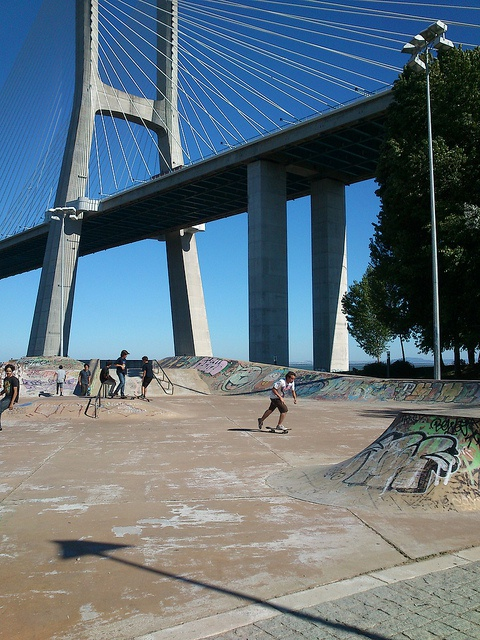Describe the objects in this image and their specific colors. I can see people in blue, black, gray, maroon, and darkgray tones, people in blue, black, gray, and darkgray tones, people in blue, black, gray, and navy tones, people in blue, black, gray, tan, and brown tones, and people in blue, black, and gray tones in this image. 